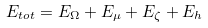<formula> <loc_0><loc_0><loc_500><loc_500>E _ { t o t } = E _ { \Omega } + E _ { \mu } + E _ { \zeta } + E _ { h }</formula> 